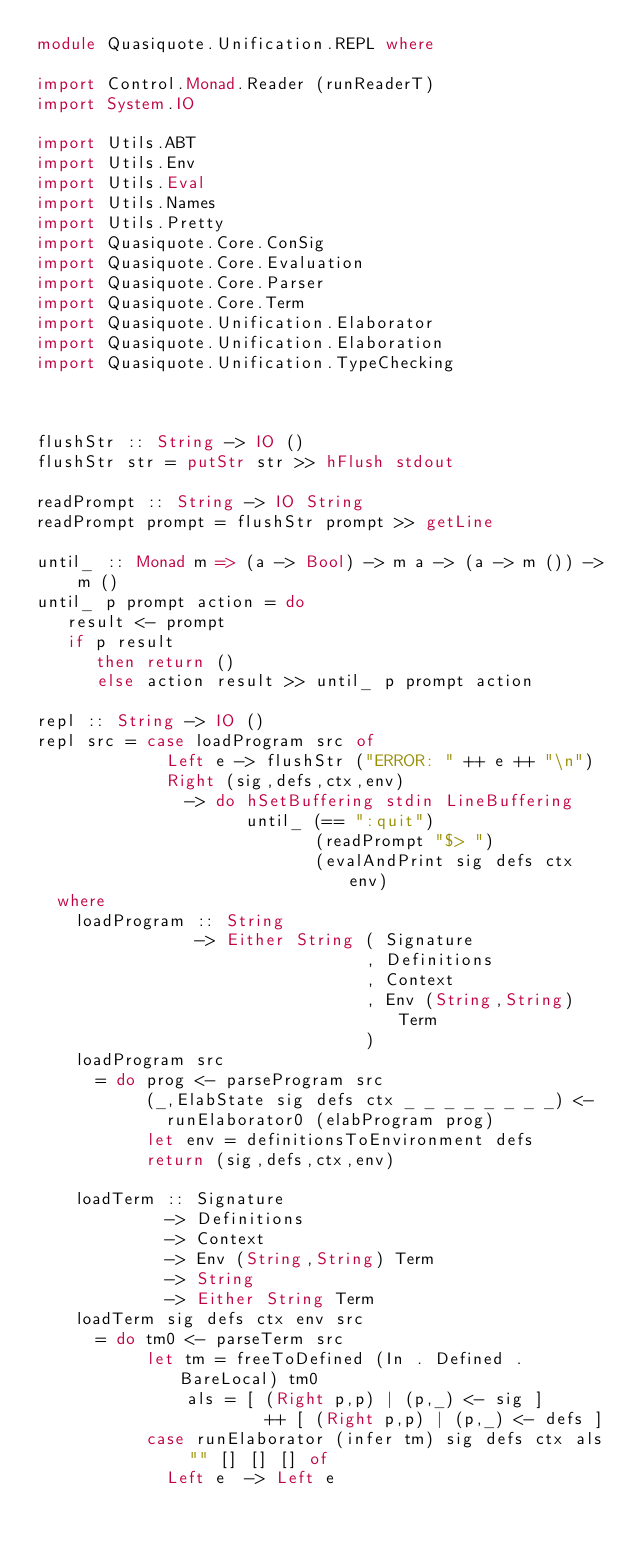Convert code to text. <code><loc_0><loc_0><loc_500><loc_500><_Haskell_>module Quasiquote.Unification.REPL where

import Control.Monad.Reader (runReaderT)
import System.IO

import Utils.ABT
import Utils.Env
import Utils.Eval
import Utils.Names
import Utils.Pretty
import Quasiquote.Core.ConSig
import Quasiquote.Core.Evaluation
import Quasiquote.Core.Parser
import Quasiquote.Core.Term
import Quasiquote.Unification.Elaborator
import Quasiquote.Unification.Elaboration
import Quasiquote.Unification.TypeChecking



flushStr :: String -> IO ()
flushStr str = putStr str >> hFlush stdout

readPrompt :: String -> IO String
readPrompt prompt = flushStr prompt >> getLine

until_ :: Monad m => (a -> Bool) -> m a -> (a -> m ()) -> m ()
until_ p prompt action = do 
   result <- prompt
   if p result 
      then return ()
      else action result >> until_ p prompt action

repl :: String -> IO ()
repl src = case loadProgram src of
             Left e -> flushStr ("ERROR: " ++ e ++ "\n")
             Right (sig,defs,ctx,env)
               -> do hSetBuffering stdin LineBuffering
                     until_ (== ":quit")
                            (readPrompt "$> ")
                            (evalAndPrint sig defs ctx env)
  where
    loadProgram :: String
                -> Either String ( Signature
                                 , Definitions
                                 , Context
                                 , Env (String,String) Term
                                 )
    loadProgram src
      = do prog <- parseProgram src
           (_,ElabState sig defs ctx _ _ _ _ _ _ _ _) <-
             runElaborator0 (elabProgram prog)
           let env = definitionsToEnvironment defs
           return (sig,defs,ctx,env)
    
    loadTerm :: Signature
             -> Definitions
             -> Context
             -> Env (String,String) Term
             -> String
             -> Either String Term
    loadTerm sig defs ctx env src
      = do tm0 <- parseTerm src
           let tm = freeToDefined (In . Defined . BareLocal) tm0
               als = [ (Right p,p) | (p,_) <- sig ]
                       ++ [ (Right p,p) | (p,_) <- defs ]
           case runElaborator (infer tm) sig defs ctx als "" [] [] [] of
             Left e  -> Left e</code> 